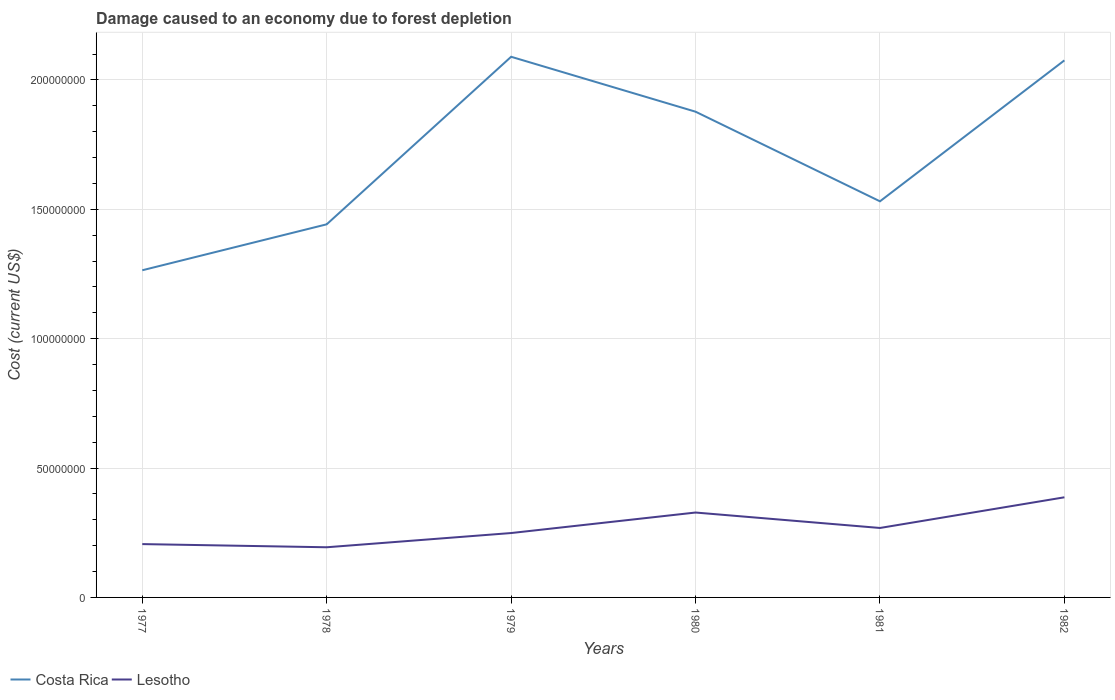How many different coloured lines are there?
Give a very brief answer. 2. Across all years, what is the maximum cost of damage caused due to forest depletion in Lesotho?
Offer a terse response. 1.94e+07. In which year was the cost of damage caused due to forest depletion in Lesotho maximum?
Offer a terse response. 1978. What is the total cost of damage caused due to forest depletion in Lesotho in the graph?
Offer a very short reply. -5.50e+06. What is the difference between the highest and the second highest cost of damage caused due to forest depletion in Costa Rica?
Your response must be concise. 8.25e+07. What is the difference between the highest and the lowest cost of damage caused due to forest depletion in Lesotho?
Offer a terse response. 2. What is the difference between two consecutive major ticks on the Y-axis?
Your answer should be very brief. 5.00e+07. Are the values on the major ticks of Y-axis written in scientific E-notation?
Make the answer very short. No. Does the graph contain any zero values?
Your answer should be compact. No. Does the graph contain grids?
Make the answer very short. Yes. Where does the legend appear in the graph?
Ensure brevity in your answer.  Bottom left. How many legend labels are there?
Your response must be concise. 2. What is the title of the graph?
Your answer should be compact. Damage caused to an economy due to forest depletion. What is the label or title of the X-axis?
Keep it short and to the point. Years. What is the label or title of the Y-axis?
Your answer should be compact. Cost (current US$). What is the Cost (current US$) of Costa Rica in 1977?
Your response must be concise. 1.26e+08. What is the Cost (current US$) of Lesotho in 1977?
Ensure brevity in your answer.  2.06e+07. What is the Cost (current US$) of Costa Rica in 1978?
Provide a short and direct response. 1.44e+08. What is the Cost (current US$) in Lesotho in 1978?
Make the answer very short. 1.94e+07. What is the Cost (current US$) in Costa Rica in 1979?
Ensure brevity in your answer.  2.09e+08. What is the Cost (current US$) of Lesotho in 1979?
Provide a short and direct response. 2.49e+07. What is the Cost (current US$) of Costa Rica in 1980?
Provide a short and direct response. 1.88e+08. What is the Cost (current US$) in Lesotho in 1980?
Give a very brief answer. 3.28e+07. What is the Cost (current US$) of Costa Rica in 1981?
Provide a short and direct response. 1.53e+08. What is the Cost (current US$) of Lesotho in 1981?
Ensure brevity in your answer.  2.68e+07. What is the Cost (current US$) in Costa Rica in 1982?
Give a very brief answer. 2.08e+08. What is the Cost (current US$) in Lesotho in 1982?
Offer a very short reply. 3.87e+07. Across all years, what is the maximum Cost (current US$) of Costa Rica?
Your response must be concise. 2.09e+08. Across all years, what is the maximum Cost (current US$) of Lesotho?
Your answer should be very brief. 3.87e+07. Across all years, what is the minimum Cost (current US$) in Costa Rica?
Make the answer very short. 1.26e+08. Across all years, what is the minimum Cost (current US$) in Lesotho?
Keep it short and to the point. 1.94e+07. What is the total Cost (current US$) of Costa Rica in the graph?
Provide a short and direct response. 1.03e+09. What is the total Cost (current US$) of Lesotho in the graph?
Ensure brevity in your answer.  1.63e+08. What is the difference between the Cost (current US$) in Costa Rica in 1977 and that in 1978?
Your answer should be very brief. -1.78e+07. What is the difference between the Cost (current US$) of Lesotho in 1977 and that in 1978?
Your answer should be compact. 1.23e+06. What is the difference between the Cost (current US$) of Costa Rica in 1977 and that in 1979?
Offer a terse response. -8.25e+07. What is the difference between the Cost (current US$) of Lesotho in 1977 and that in 1979?
Give a very brief answer. -4.27e+06. What is the difference between the Cost (current US$) of Costa Rica in 1977 and that in 1980?
Offer a terse response. -6.13e+07. What is the difference between the Cost (current US$) in Lesotho in 1977 and that in 1980?
Ensure brevity in your answer.  -1.22e+07. What is the difference between the Cost (current US$) of Costa Rica in 1977 and that in 1981?
Your answer should be compact. -2.66e+07. What is the difference between the Cost (current US$) of Lesotho in 1977 and that in 1981?
Provide a succinct answer. -6.23e+06. What is the difference between the Cost (current US$) of Costa Rica in 1977 and that in 1982?
Make the answer very short. -8.11e+07. What is the difference between the Cost (current US$) in Lesotho in 1977 and that in 1982?
Your response must be concise. -1.81e+07. What is the difference between the Cost (current US$) of Costa Rica in 1978 and that in 1979?
Ensure brevity in your answer.  -6.47e+07. What is the difference between the Cost (current US$) of Lesotho in 1978 and that in 1979?
Offer a very short reply. -5.50e+06. What is the difference between the Cost (current US$) of Costa Rica in 1978 and that in 1980?
Make the answer very short. -4.35e+07. What is the difference between the Cost (current US$) of Lesotho in 1978 and that in 1980?
Make the answer very short. -1.34e+07. What is the difference between the Cost (current US$) of Costa Rica in 1978 and that in 1981?
Make the answer very short. -8.89e+06. What is the difference between the Cost (current US$) of Lesotho in 1978 and that in 1981?
Offer a terse response. -7.46e+06. What is the difference between the Cost (current US$) in Costa Rica in 1978 and that in 1982?
Offer a very short reply. -6.34e+07. What is the difference between the Cost (current US$) of Lesotho in 1978 and that in 1982?
Give a very brief answer. -1.93e+07. What is the difference between the Cost (current US$) in Costa Rica in 1979 and that in 1980?
Give a very brief answer. 2.12e+07. What is the difference between the Cost (current US$) in Lesotho in 1979 and that in 1980?
Offer a very short reply. -7.93e+06. What is the difference between the Cost (current US$) of Costa Rica in 1979 and that in 1981?
Offer a very short reply. 5.59e+07. What is the difference between the Cost (current US$) of Lesotho in 1979 and that in 1981?
Provide a short and direct response. -1.96e+06. What is the difference between the Cost (current US$) of Costa Rica in 1979 and that in 1982?
Your answer should be very brief. 1.39e+06. What is the difference between the Cost (current US$) in Lesotho in 1979 and that in 1982?
Provide a short and direct response. -1.38e+07. What is the difference between the Cost (current US$) of Costa Rica in 1980 and that in 1981?
Offer a terse response. 3.46e+07. What is the difference between the Cost (current US$) of Lesotho in 1980 and that in 1981?
Give a very brief answer. 5.97e+06. What is the difference between the Cost (current US$) of Costa Rica in 1980 and that in 1982?
Offer a very short reply. -1.98e+07. What is the difference between the Cost (current US$) in Lesotho in 1980 and that in 1982?
Keep it short and to the point. -5.89e+06. What is the difference between the Cost (current US$) in Costa Rica in 1981 and that in 1982?
Your answer should be compact. -5.45e+07. What is the difference between the Cost (current US$) of Lesotho in 1981 and that in 1982?
Make the answer very short. -1.19e+07. What is the difference between the Cost (current US$) of Costa Rica in 1977 and the Cost (current US$) of Lesotho in 1978?
Give a very brief answer. 1.07e+08. What is the difference between the Cost (current US$) in Costa Rica in 1977 and the Cost (current US$) in Lesotho in 1979?
Provide a short and direct response. 1.02e+08. What is the difference between the Cost (current US$) in Costa Rica in 1977 and the Cost (current US$) in Lesotho in 1980?
Your response must be concise. 9.36e+07. What is the difference between the Cost (current US$) in Costa Rica in 1977 and the Cost (current US$) in Lesotho in 1981?
Give a very brief answer. 9.96e+07. What is the difference between the Cost (current US$) in Costa Rica in 1977 and the Cost (current US$) in Lesotho in 1982?
Provide a short and direct response. 8.77e+07. What is the difference between the Cost (current US$) in Costa Rica in 1978 and the Cost (current US$) in Lesotho in 1979?
Your answer should be compact. 1.19e+08. What is the difference between the Cost (current US$) of Costa Rica in 1978 and the Cost (current US$) of Lesotho in 1980?
Ensure brevity in your answer.  1.11e+08. What is the difference between the Cost (current US$) in Costa Rica in 1978 and the Cost (current US$) in Lesotho in 1981?
Make the answer very short. 1.17e+08. What is the difference between the Cost (current US$) of Costa Rica in 1978 and the Cost (current US$) of Lesotho in 1982?
Provide a short and direct response. 1.06e+08. What is the difference between the Cost (current US$) of Costa Rica in 1979 and the Cost (current US$) of Lesotho in 1980?
Your response must be concise. 1.76e+08. What is the difference between the Cost (current US$) in Costa Rica in 1979 and the Cost (current US$) in Lesotho in 1981?
Your response must be concise. 1.82e+08. What is the difference between the Cost (current US$) in Costa Rica in 1979 and the Cost (current US$) in Lesotho in 1982?
Provide a succinct answer. 1.70e+08. What is the difference between the Cost (current US$) of Costa Rica in 1980 and the Cost (current US$) of Lesotho in 1981?
Give a very brief answer. 1.61e+08. What is the difference between the Cost (current US$) of Costa Rica in 1980 and the Cost (current US$) of Lesotho in 1982?
Your answer should be compact. 1.49e+08. What is the difference between the Cost (current US$) of Costa Rica in 1981 and the Cost (current US$) of Lesotho in 1982?
Provide a short and direct response. 1.14e+08. What is the average Cost (current US$) in Costa Rica per year?
Your response must be concise. 1.71e+08. What is the average Cost (current US$) in Lesotho per year?
Offer a very short reply. 2.72e+07. In the year 1977, what is the difference between the Cost (current US$) of Costa Rica and Cost (current US$) of Lesotho?
Provide a short and direct response. 1.06e+08. In the year 1978, what is the difference between the Cost (current US$) in Costa Rica and Cost (current US$) in Lesotho?
Provide a succinct answer. 1.25e+08. In the year 1979, what is the difference between the Cost (current US$) of Costa Rica and Cost (current US$) of Lesotho?
Offer a terse response. 1.84e+08. In the year 1980, what is the difference between the Cost (current US$) of Costa Rica and Cost (current US$) of Lesotho?
Ensure brevity in your answer.  1.55e+08. In the year 1981, what is the difference between the Cost (current US$) of Costa Rica and Cost (current US$) of Lesotho?
Provide a succinct answer. 1.26e+08. In the year 1982, what is the difference between the Cost (current US$) in Costa Rica and Cost (current US$) in Lesotho?
Provide a short and direct response. 1.69e+08. What is the ratio of the Cost (current US$) of Costa Rica in 1977 to that in 1978?
Offer a very short reply. 0.88. What is the ratio of the Cost (current US$) in Lesotho in 1977 to that in 1978?
Provide a succinct answer. 1.06. What is the ratio of the Cost (current US$) in Costa Rica in 1977 to that in 1979?
Give a very brief answer. 0.61. What is the ratio of the Cost (current US$) in Lesotho in 1977 to that in 1979?
Give a very brief answer. 0.83. What is the ratio of the Cost (current US$) in Costa Rica in 1977 to that in 1980?
Keep it short and to the point. 0.67. What is the ratio of the Cost (current US$) in Lesotho in 1977 to that in 1980?
Make the answer very short. 0.63. What is the ratio of the Cost (current US$) in Costa Rica in 1977 to that in 1981?
Make the answer very short. 0.83. What is the ratio of the Cost (current US$) of Lesotho in 1977 to that in 1981?
Your answer should be compact. 0.77. What is the ratio of the Cost (current US$) of Costa Rica in 1977 to that in 1982?
Give a very brief answer. 0.61. What is the ratio of the Cost (current US$) of Lesotho in 1977 to that in 1982?
Provide a short and direct response. 0.53. What is the ratio of the Cost (current US$) in Costa Rica in 1978 to that in 1979?
Your response must be concise. 0.69. What is the ratio of the Cost (current US$) of Lesotho in 1978 to that in 1979?
Keep it short and to the point. 0.78. What is the ratio of the Cost (current US$) in Costa Rica in 1978 to that in 1980?
Provide a short and direct response. 0.77. What is the ratio of the Cost (current US$) in Lesotho in 1978 to that in 1980?
Make the answer very short. 0.59. What is the ratio of the Cost (current US$) in Costa Rica in 1978 to that in 1981?
Your response must be concise. 0.94. What is the ratio of the Cost (current US$) of Lesotho in 1978 to that in 1981?
Offer a very short reply. 0.72. What is the ratio of the Cost (current US$) of Costa Rica in 1978 to that in 1982?
Offer a very short reply. 0.69. What is the ratio of the Cost (current US$) of Lesotho in 1978 to that in 1982?
Give a very brief answer. 0.5. What is the ratio of the Cost (current US$) of Costa Rica in 1979 to that in 1980?
Your answer should be compact. 1.11. What is the ratio of the Cost (current US$) in Lesotho in 1979 to that in 1980?
Provide a short and direct response. 0.76. What is the ratio of the Cost (current US$) in Costa Rica in 1979 to that in 1981?
Your response must be concise. 1.36. What is the ratio of the Cost (current US$) in Lesotho in 1979 to that in 1981?
Your answer should be compact. 0.93. What is the ratio of the Cost (current US$) of Costa Rica in 1979 to that in 1982?
Ensure brevity in your answer.  1.01. What is the ratio of the Cost (current US$) in Lesotho in 1979 to that in 1982?
Provide a short and direct response. 0.64. What is the ratio of the Cost (current US$) of Costa Rica in 1980 to that in 1981?
Make the answer very short. 1.23. What is the ratio of the Cost (current US$) in Lesotho in 1980 to that in 1981?
Your answer should be compact. 1.22. What is the ratio of the Cost (current US$) in Costa Rica in 1980 to that in 1982?
Offer a terse response. 0.9. What is the ratio of the Cost (current US$) of Lesotho in 1980 to that in 1982?
Keep it short and to the point. 0.85. What is the ratio of the Cost (current US$) in Costa Rica in 1981 to that in 1982?
Keep it short and to the point. 0.74. What is the ratio of the Cost (current US$) of Lesotho in 1981 to that in 1982?
Offer a terse response. 0.69. What is the difference between the highest and the second highest Cost (current US$) in Costa Rica?
Your response must be concise. 1.39e+06. What is the difference between the highest and the second highest Cost (current US$) of Lesotho?
Offer a terse response. 5.89e+06. What is the difference between the highest and the lowest Cost (current US$) of Costa Rica?
Ensure brevity in your answer.  8.25e+07. What is the difference between the highest and the lowest Cost (current US$) in Lesotho?
Offer a very short reply. 1.93e+07. 